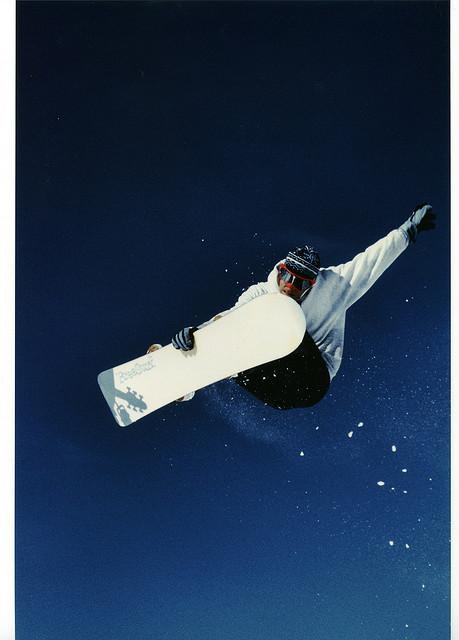Is the man leaping or falling?
Be succinct. Leaping. Is it day or night?
Answer briefly. Day. What is the white stuff falling below the man?
Quick response, please. Snow. 